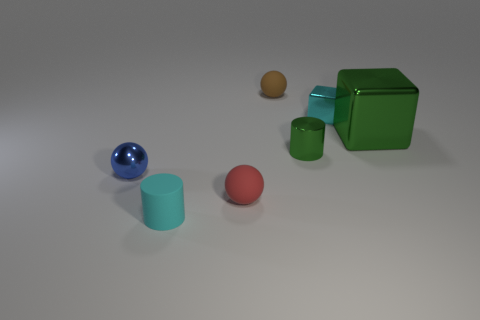Is there a yellow matte thing that has the same shape as the small red thing?
Give a very brief answer. No. Does the big object have the same shape as the tiny brown thing?
Make the answer very short. No. The small cylinder right of the small cylinder that is on the left side of the brown rubber sphere is what color?
Your answer should be very brief. Green. There is a shiny sphere that is the same size as the brown rubber object; what is its color?
Offer a very short reply. Blue. What number of shiny things are large brown things or small cyan blocks?
Keep it short and to the point. 1. How many small green metallic objects are in front of the tiny metallic thing to the left of the red ball?
Offer a terse response. 0. There is a metallic block that is the same color as the tiny shiny cylinder; what is its size?
Offer a very short reply. Large. How many things are brown spheres or small balls in front of the big cube?
Provide a succinct answer. 3. Is there a small gray block made of the same material as the tiny brown sphere?
Keep it short and to the point. No. What number of cyan things are both in front of the red sphere and right of the brown sphere?
Provide a succinct answer. 0. 